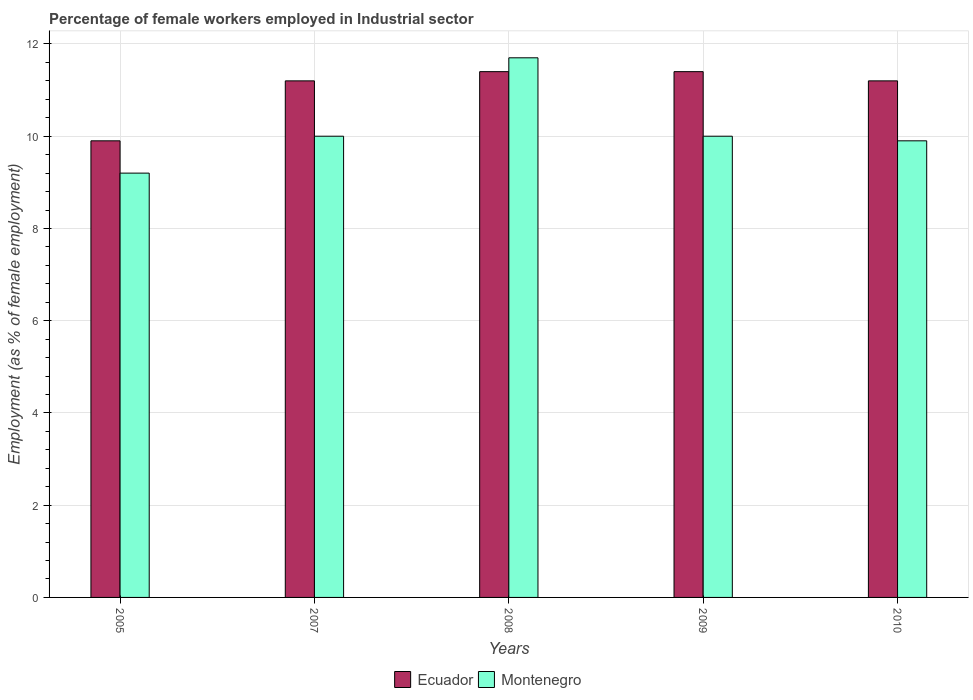How many different coloured bars are there?
Offer a very short reply. 2. How many groups of bars are there?
Keep it short and to the point. 5. Are the number of bars on each tick of the X-axis equal?
Your answer should be compact. Yes. What is the label of the 5th group of bars from the left?
Provide a succinct answer. 2010. In how many cases, is the number of bars for a given year not equal to the number of legend labels?
Give a very brief answer. 0. What is the percentage of females employed in Industrial sector in Ecuador in 2010?
Your answer should be very brief. 11.2. Across all years, what is the maximum percentage of females employed in Industrial sector in Ecuador?
Ensure brevity in your answer.  11.4. Across all years, what is the minimum percentage of females employed in Industrial sector in Montenegro?
Your answer should be very brief. 9.2. What is the total percentage of females employed in Industrial sector in Ecuador in the graph?
Keep it short and to the point. 55.1. What is the difference between the percentage of females employed in Industrial sector in Montenegro in 2009 and that in 2010?
Keep it short and to the point. 0.1. What is the difference between the percentage of females employed in Industrial sector in Ecuador in 2008 and the percentage of females employed in Industrial sector in Montenegro in 2010?
Your answer should be compact. 1.5. What is the average percentage of females employed in Industrial sector in Montenegro per year?
Offer a terse response. 10.16. In the year 2008, what is the difference between the percentage of females employed in Industrial sector in Montenegro and percentage of females employed in Industrial sector in Ecuador?
Make the answer very short. 0.3. In how many years, is the percentage of females employed in Industrial sector in Ecuador greater than 3.6 %?
Ensure brevity in your answer.  5. What is the ratio of the percentage of females employed in Industrial sector in Montenegro in 2007 to that in 2010?
Provide a succinct answer. 1.01. Is the difference between the percentage of females employed in Industrial sector in Montenegro in 2005 and 2007 greater than the difference between the percentage of females employed in Industrial sector in Ecuador in 2005 and 2007?
Provide a short and direct response. Yes. What is the difference between the highest and the lowest percentage of females employed in Industrial sector in Ecuador?
Your response must be concise. 1.5. In how many years, is the percentage of females employed in Industrial sector in Ecuador greater than the average percentage of females employed in Industrial sector in Ecuador taken over all years?
Provide a succinct answer. 4. Is the sum of the percentage of females employed in Industrial sector in Montenegro in 2007 and 2010 greater than the maximum percentage of females employed in Industrial sector in Ecuador across all years?
Your answer should be very brief. Yes. What does the 1st bar from the left in 2010 represents?
Provide a succinct answer. Ecuador. What does the 2nd bar from the right in 2010 represents?
Give a very brief answer. Ecuador. Are all the bars in the graph horizontal?
Keep it short and to the point. No. How many years are there in the graph?
Keep it short and to the point. 5. Does the graph contain any zero values?
Provide a succinct answer. No. How many legend labels are there?
Provide a succinct answer. 2. What is the title of the graph?
Ensure brevity in your answer.  Percentage of female workers employed in Industrial sector. What is the label or title of the Y-axis?
Ensure brevity in your answer.  Employment (as % of female employment). What is the Employment (as % of female employment) of Ecuador in 2005?
Keep it short and to the point. 9.9. What is the Employment (as % of female employment) of Montenegro in 2005?
Offer a very short reply. 9.2. What is the Employment (as % of female employment) of Ecuador in 2007?
Ensure brevity in your answer.  11.2. What is the Employment (as % of female employment) in Montenegro in 2007?
Make the answer very short. 10. What is the Employment (as % of female employment) of Ecuador in 2008?
Ensure brevity in your answer.  11.4. What is the Employment (as % of female employment) of Montenegro in 2008?
Your answer should be very brief. 11.7. What is the Employment (as % of female employment) in Ecuador in 2009?
Give a very brief answer. 11.4. What is the Employment (as % of female employment) in Ecuador in 2010?
Make the answer very short. 11.2. What is the Employment (as % of female employment) in Montenegro in 2010?
Keep it short and to the point. 9.9. Across all years, what is the maximum Employment (as % of female employment) in Ecuador?
Make the answer very short. 11.4. Across all years, what is the maximum Employment (as % of female employment) in Montenegro?
Provide a short and direct response. 11.7. Across all years, what is the minimum Employment (as % of female employment) of Ecuador?
Offer a very short reply. 9.9. Across all years, what is the minimum Employment (as % of female employment) in Montenegro?
Offer a terse response. 9.2. What is the total Employment (as % of female employment) of Ecuador in the graph?
Your answer should be compact. 55.1. What is the total Employment (as % of female employment) in Montenegro in the graph?
Provide a short and direct response. 50.8. What is the difference between the Employment (as % of female employment) in Ecuador in 2005 and that in 2007?
Offer a terse response. -1.3. What is the difference between the Employment (as % of female employment) of Montenegro in 2005 and that in 2007?
Provide a succinct answer. -0.8. What is the difference between the Employment (as % of female employment) of Ecuador in 2005 and that in 2008?
Your answer should be very brief. -1.5. What is the difference between the Employment (as % of female employment) in Montenegro in 2005 and that in 2008?
Provide a short and direct response. -2.5. What is the difference between the Employment (as % of female employment) in Ecuador in 2005 and that in 2009?
Your answer should be very brief. -1.5. What is the difference between the Employment (as % of female employment) of Montenegro in 2005 and that in 2009?
Offer a very short reply. -0.8. What is the difference between the Employment (as % of female employment) of Montenegro in 2005 and that in 2010?
Keep it short and to the point. -0.7. What is the difference between the Employment (as % of female employment) in Montenegro in 2007 and that in 2008?
Your answer should be very brief. -1.7. What is the difference between the Employment (as % of female employment) of Montenegro in 2007 and that in 2009?
Make the answer very short. 0. What is the difference between the Employment (as % of female employment) of Ecuador in 2007 and that in 2010?
Your answer should be very brief. 0. What is the difference between the Employment (as % of female employment) of Montenegro in 2008 and that in 2009?
Make the answer very short. 1.7. What is the difference between the Employment (as % of female employment) of Ecuador in 2008 and that in 2010?
Provide a short and direct response. 0.2. What is the difference between the Employment (as % of female employment) of Ecuador in 2009 and that in 2010?
Offer a very short reply. 0.2. What is the difference between the Employment (as % of female employment) in Montenegro in 2009 and that in 2010?
Your response must be concise. 0.1. What is the difference between the Employment (as % of female employment) in Ecuador in 2005 and the Employment (as % of female employment) in Montenegro in 2007?
Make the answer very short. -0.1. What is the difference between the Employment (as % of female employment) of Ecuador in 2005 and the Employment (as % of female employment) of Montenegro in 2008?
Your response must be concise. -1.8. What is the difference between the Employment (as % of female employment) in Ecuador in 2007 and the Employment (as % of female employment) in Montenegro in 2008?
Your answer should be compact. -0.5. What is the difference between the Employment (as % of female employment) in Ecuador in 2008 and the Employment (as % of female employment) in Montenegro in 2009?
Offer a very short reply. 1.4. What is the difference between the Employment (as % of female employment) of Ecuador in 2008 and the Employment (as % of female employment) of Montenegro in 2010?
Your answer should be compact. 1.5. What is the average Employment (as % of female employment) in Ecuador per year?
Ensure brevity in your answer.  11.02. What is the average Employment (as % of female employment) in Montenegro per year?
Provide a short and direct response. 10.16. In the year 2007, what is the difference between the Employment (as % of female employment) of Ecuador and Employment (as % of female employment) of Montenegro?
Provide a short and direct response. 1.2. In the year 2009, what is the difference between the Employment (as % of female employment) of Ecuador and Employment (as % of female employment) of Montenegro?
Ensure brevity in your answer.  1.4. What is the ratio of the Employment (as % of female employment) of Ecuador in 2005 to that in 2007?
Your answer should be compact. 0.88. What is the ratio of the Employment (as % of female employment) in Montenegro in 2005 to that in 2007?
Offer a terse response. 0.92. What is the ratio of the Employment (as % of female employment) in Ecuador in 2005 to that in 2008?
Your answer should be very brief. 0.87. What is the ratio of the Employment (as % of female employment) of Montenegro in 2005 to that in 2008?
Your answer should be compact. 0.79. What is the ratio of the Employment (as % of female employment) of Ecuador in 2005 to that in 2009?
Your answer should be very brief. 0.87. What is the ratio of the Employment (as % of female employment) in Ecuador in 2005 to that in 2010?
Provide a succinct answer. 0.88. What is the ratio of the Employment (as % of female employment) in Montenegro in 2005 to that in 2010?
Ensure brevity in your answer.  0.93. What is the ratio of the Employment (as % of female employment) of Ecuador in 2007 to that in 2008?
Keep it short and to the point. 0.98. What is the ratio of the Employment (as % of female employment) of Montenegro in 2007 to that in 2008?
Your answer should be compact. 0.85. What is the ratio of the Employment (as % of female employment) in Ecuador in 2007 to that in 2009?
Your answer should be compact. 0.98. What is the ratio of the Employment (as % of female employment) in Ecuador in 2007 to that in 2010?
Your answer should be compact. 1. What is the ratio of the Employment (as % of female employment) of Montenegro in 2007 to that in 2010?
Make the answer very short. 1.01. What is the ratio of the Employment (as % of female employment) in Ecuador in 2008 to that in 2009?
Your answer should be very brief. 1. What is the ratio of the Employment (as % of female employment) in Montenegro in 2008 to that in 2009?
Ensure brevity in your answer.  1.17. What is the ratio of the Employment (as % of female employment) in Ecuador in 2008 to that in 2010?
Make the answer very short. 1.02. What is the ratio of the Employment (as % of female employment) of Montenegro in 2008 to that in 2010?
Make the answer very short. 1.18. What is the ratio of the Employment (as % of female employment) of Ecuador in 2009 to that in 2010?
Keep it short and to the point. 1.02. What is the difference between the highest and the second highest Employment (as % of female employment) in Ecuador?
Make the answer very short. 0. What is the difference between the highest and the lowest Employment (as % of female employment) of Montenegro?
Provide a succinct answer. 2.5. 